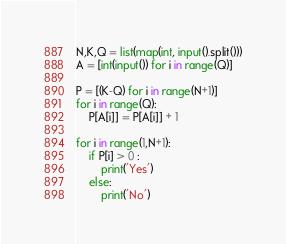Convert code to text. <code><loc_0><loc_0><loc_500><loc_500><_Python_>N,K,Q = list(map(int, input().split()))
A = [int(input()) for i in range(Q)]

P = [(K-Q) for i in range(N+1)]
for i in range(Q):
    P[A[i]] = P[A[i]] + 1 

for i in range(1,N+1):
    if P[i] > 0 :
        print('Yes')
    else:
        print('No')
</code> 